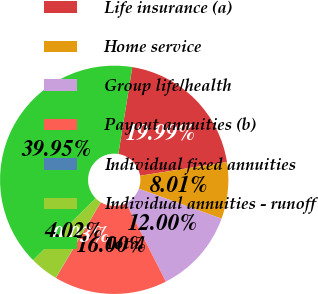Convert chart. <chart><loc_0><loc_0><loc_500><loc_500><pie_chart><fcel>Life insurance (a)<fcel>Home service<fcel>Group life/health<fcel>Payout annuities (b)<fcel>Individual fixed annuities<fcel>Individual annuities - runoff<fcel>Total<nl><fcel>19.99%<fcel>8.01%<fcel>12.0%<fcel>16.0%<fcel>0.03%<fcel>4.02%<fcel>39.95%<nl></chart> 